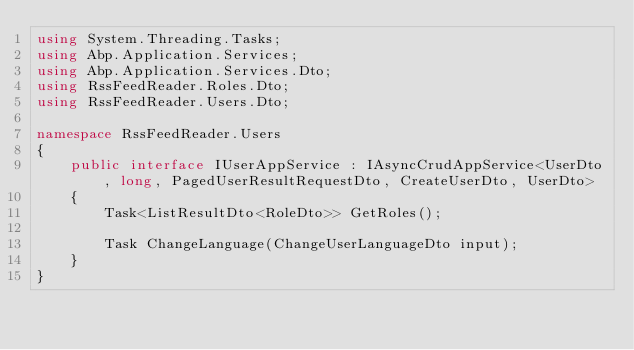<code> <loc_0><loc_0><loc_500><loc_500><_C#_>using System.Threading.Tasks;
using Abp.Application.Services;
using Abp.Application.Services.Dto;
using RssFeedReader.Roles.Dto;
using RssFeedReader.Users.Dto;

namespace RssFeedReader.Users
{
    public interface IUserAppService : IAsyncCrudAppService<UserDto, long, PagedUserResultRequestDto, CreateUserDto, UserDto>
    {
        Task<ListResultDto<RoleDto>> GetRoles();

        Task ChangeLanguage(ChangeUserLanguageDto input);
    }
}
</code> 